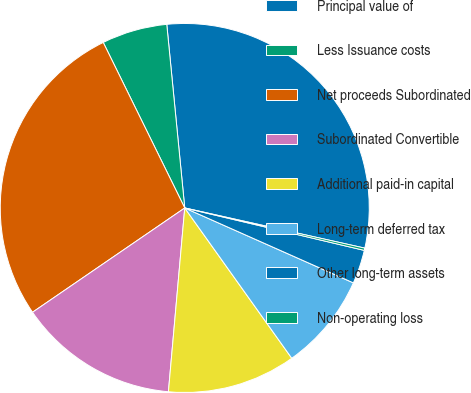Convert chart. <chart><loc_0><loc_0><loc_500><loc_500><pie_chart><fcel>Principal value of<fcel>Less Issuance costs<fcel>Net proceeds Subordinated<fcel>Subordinated Convertible<fcel>Additional paid-in capital<fcel>Long-term deferred tax<fcel>Other long-term assets<fcel>Non-operating loss<nl><fcel>30.05%<fcel>5.73%<fcel>27.28%<fcel>14.03%<fcel>11.26%<fcel>8.5%<fcel>2.96%<fcel>0.2%<nl></chart> 